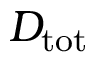<formula> <loc_0><loc_0><loc_500><loc_500>D _ { t o t }</formula> 